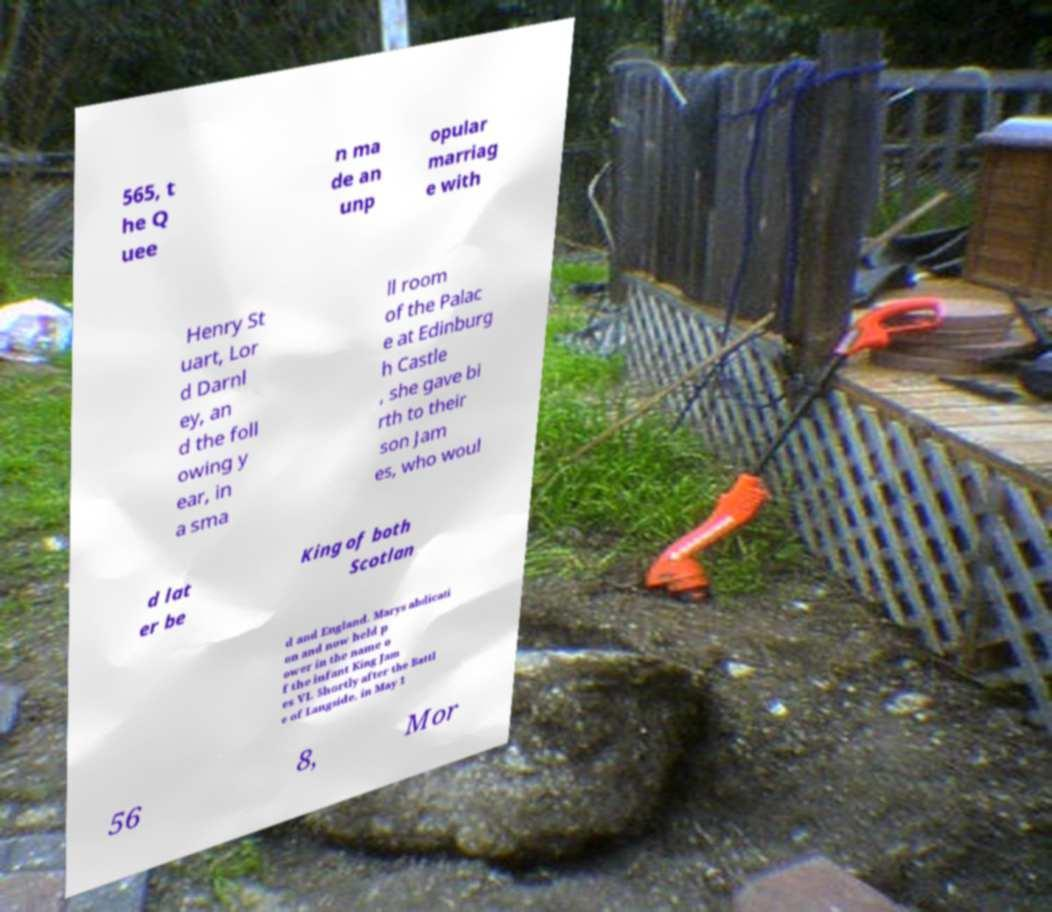What messages or text are displayed in this image? I need them in a readable, typed format. 565, t he Q uee n ma de an unp opular marriag e with Henry St uart, Lor d Darnl ey, an d the foll owing y ear, in a sma ll room of the Palac e at Edinburg h Castle , she gave bi rth to their son Jam es, who woul d lat er be King of both Scotlan d and England. Marys abdicati on and now held p ower in the name o f the infant King Jam es VI. Shortly after the Battl e of Langside, in May 1 56 8, Mor 